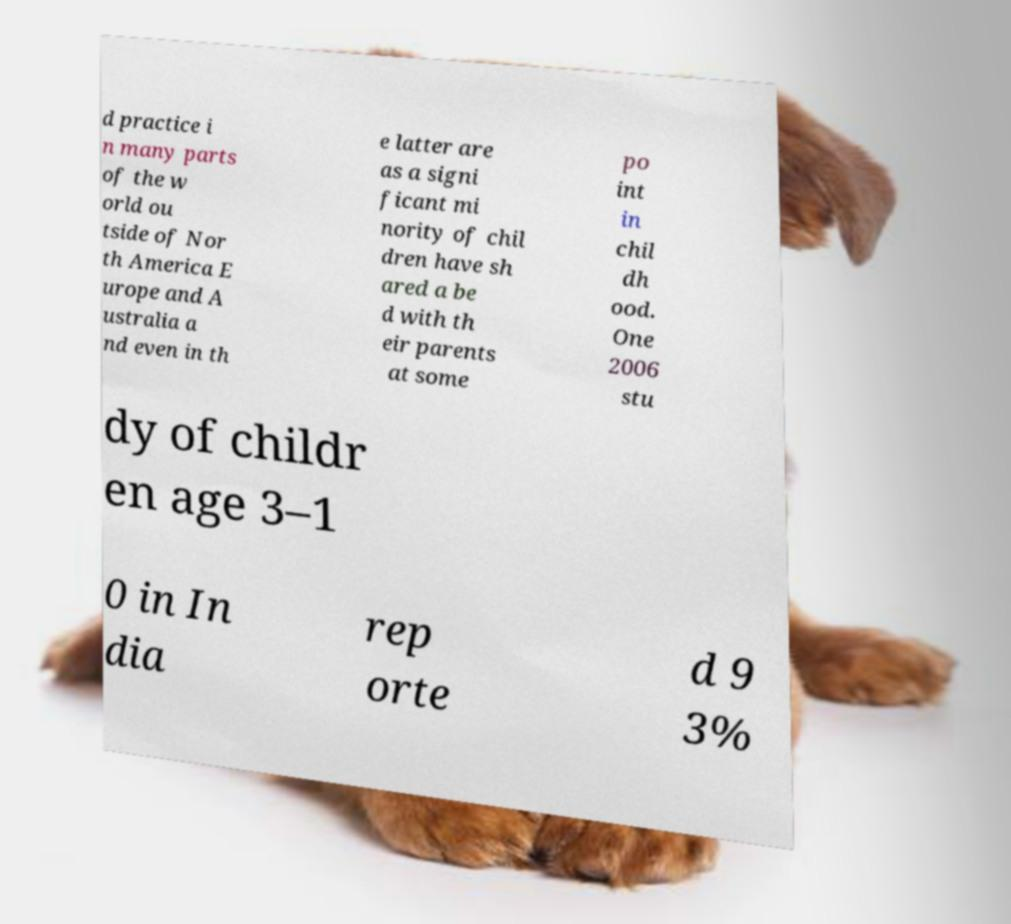Please read and relay the text visible in this image. What does it say? d practice i n many parts of the w orld ou tside of Nor th America E urope and A ustralia a nd even in th e latter are as a signi ficant mi nority of chil dren have sh ared a be d with th eir parents at some po int in chil dh ood. One 2006 stu dy of childr en age 3–1 0 in In dia rep orte d 9 3% 